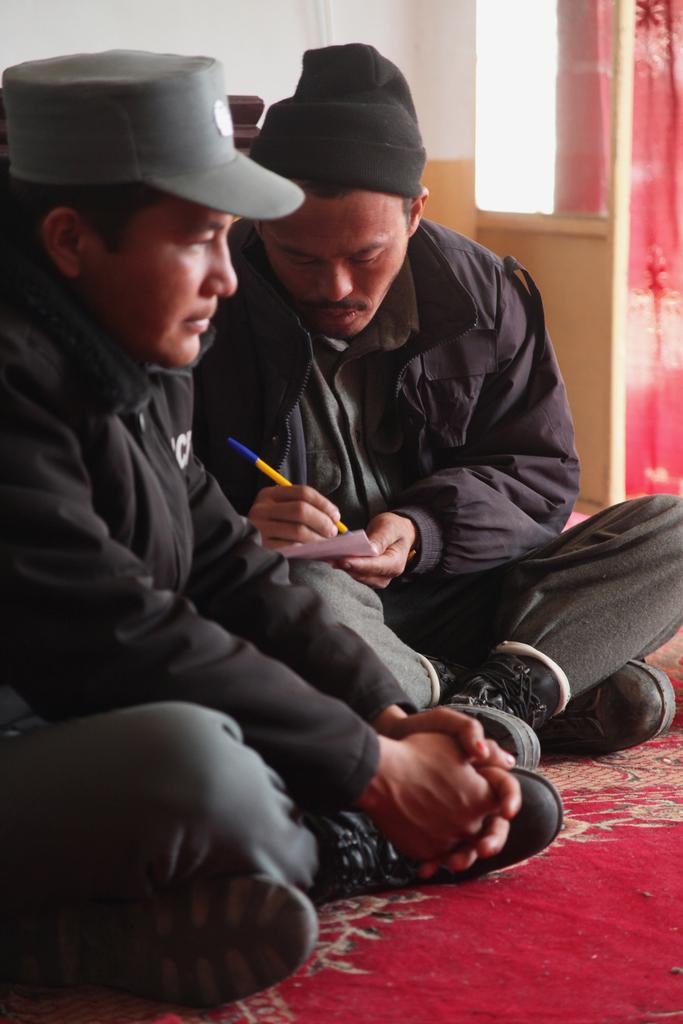How many people are in the foreground of the image? There are two men in the foreground of the image. What is one of the men holding in the image? One of the men is holding a paper and a pen. What is located at the bottom of the image? There is a carpet at the bottom of the image. What can be seen in the background of the image? There is a curtain and a wall in the background of the image. Where is the shelf located in the image? There is no shelf present in the image. Is the coat hanging on the wall in the image? There is no coat visible in the image. 